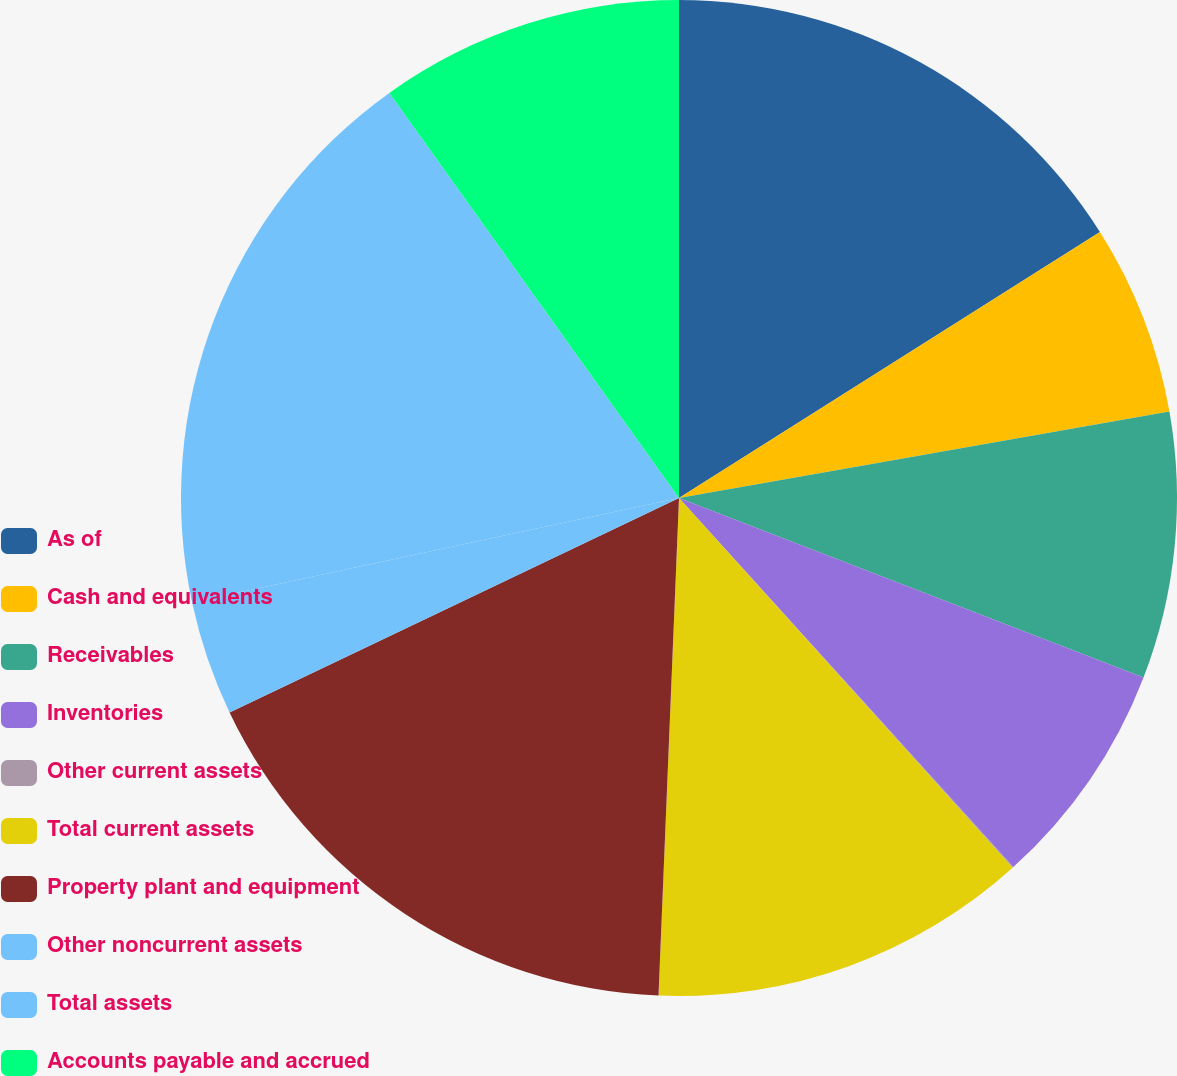Convert chart to OTSL. <chart><loc_0><loc_0><loc_500><loc_500><pie_chart><fcel>As of<fcel>Cash and equivalents<fcel>Receivables<fcel>Inventories<fcel>Other current assets<fcel>Total current assets<fcel>Property plant and equipment<fcel>Other noncurrent assets<fcel>Total assets<fcel>Accounts payable and accrued<nl><fcel>16.03%<fcel>6.19%<fcel>8.65%<fcel>7.42%<fcel>0.03%<fcel>12.34%<fcel>17.26%<fcel>3.72%<fcel>18.49%<fcel>9.88%<nl></chart> 